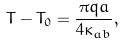Convert formula to latex. <formula><loc_0><loc_0><loc_500><loc_500>T - T _ { 0 } = \frac { \pi q a } { 4 \kappa _ { a b } } ,</formula> 